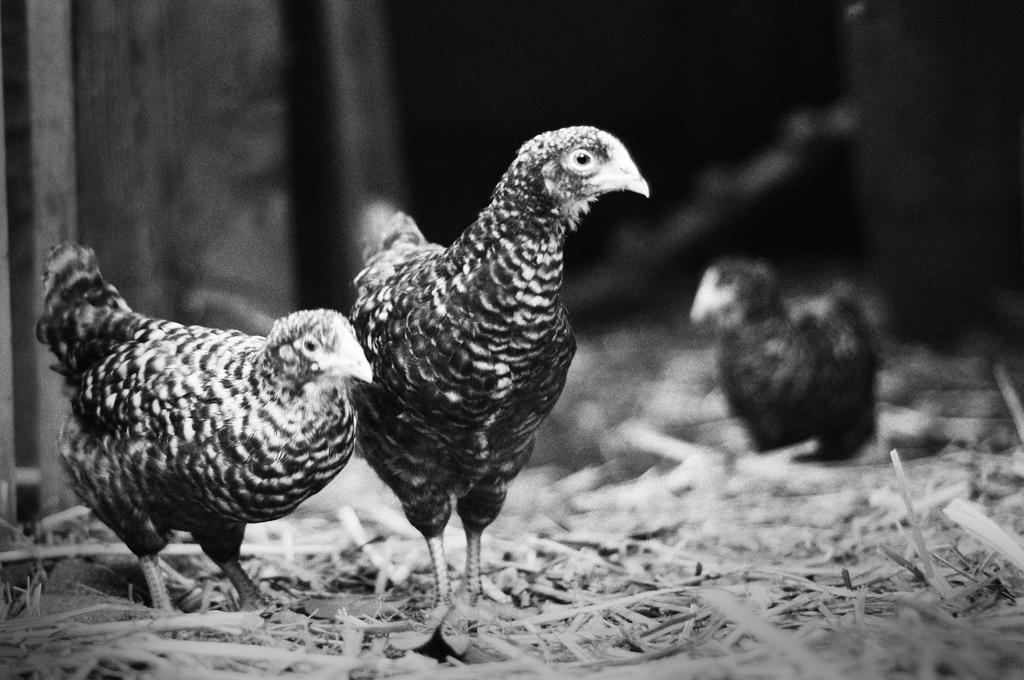What is the color scheme of the image? The image is black and white. What animals can be seen in the image? There are hens in the image. What type of vegetation is present in the image? There is dry grass in the image. How many houses can be seen in the image? There are no houses present in the image; it features hens and dry grass. What type of clock is visible in the image? There is no clock present in the image. 